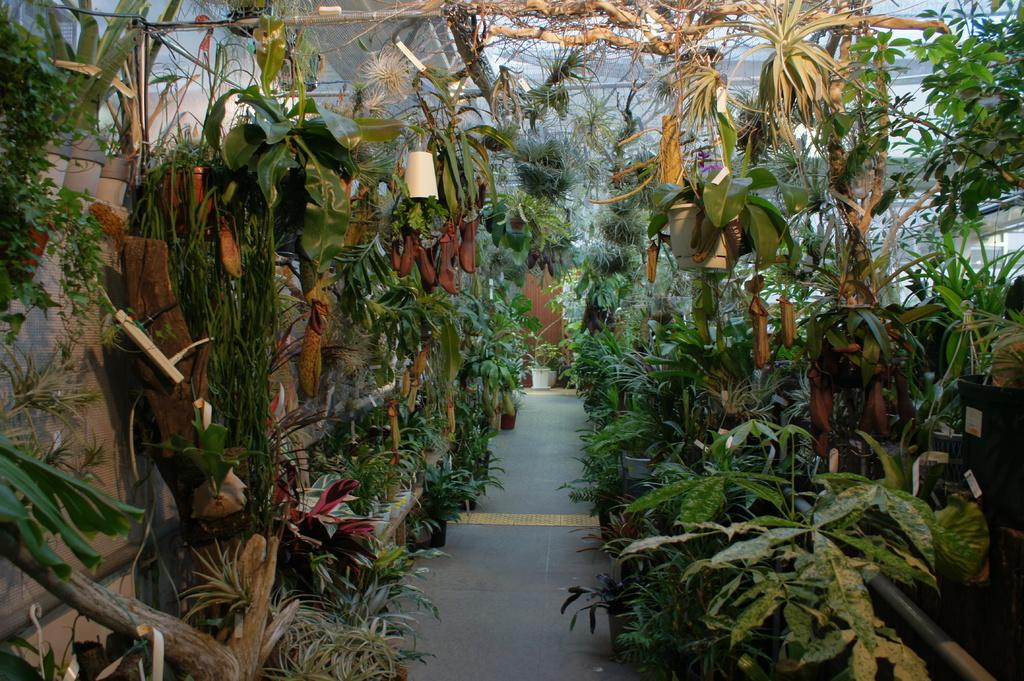What type of objects can be seen in the image? There are flower pots and plants in the image. What else can be seen in the image besides the flower pots and plants? There is a path visible in the image. What structure is visible in the background of the image? There is a door in the background of the image. Where is the hospital located in the image? There is no hospital present in the image. What type of clothing is the person wearing in the image? There is no person visible in the image, so it is impossible to determine what type of clothing they might be wearing. 